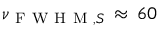Convert formula to latex. <formula><loc_0><loc_0><loc_500><loc_500>\nu _ { F W H M , S } \, \approx \, 6 0</formula> 